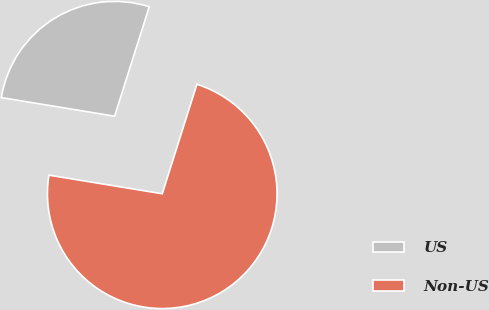<chart> <loc_0><loc_0><loc_500><loc_500><pie_chart><fcel>US<fcel>Non-US<nl><fcel>27.29%<fcel>72.71%<nl></chart> 